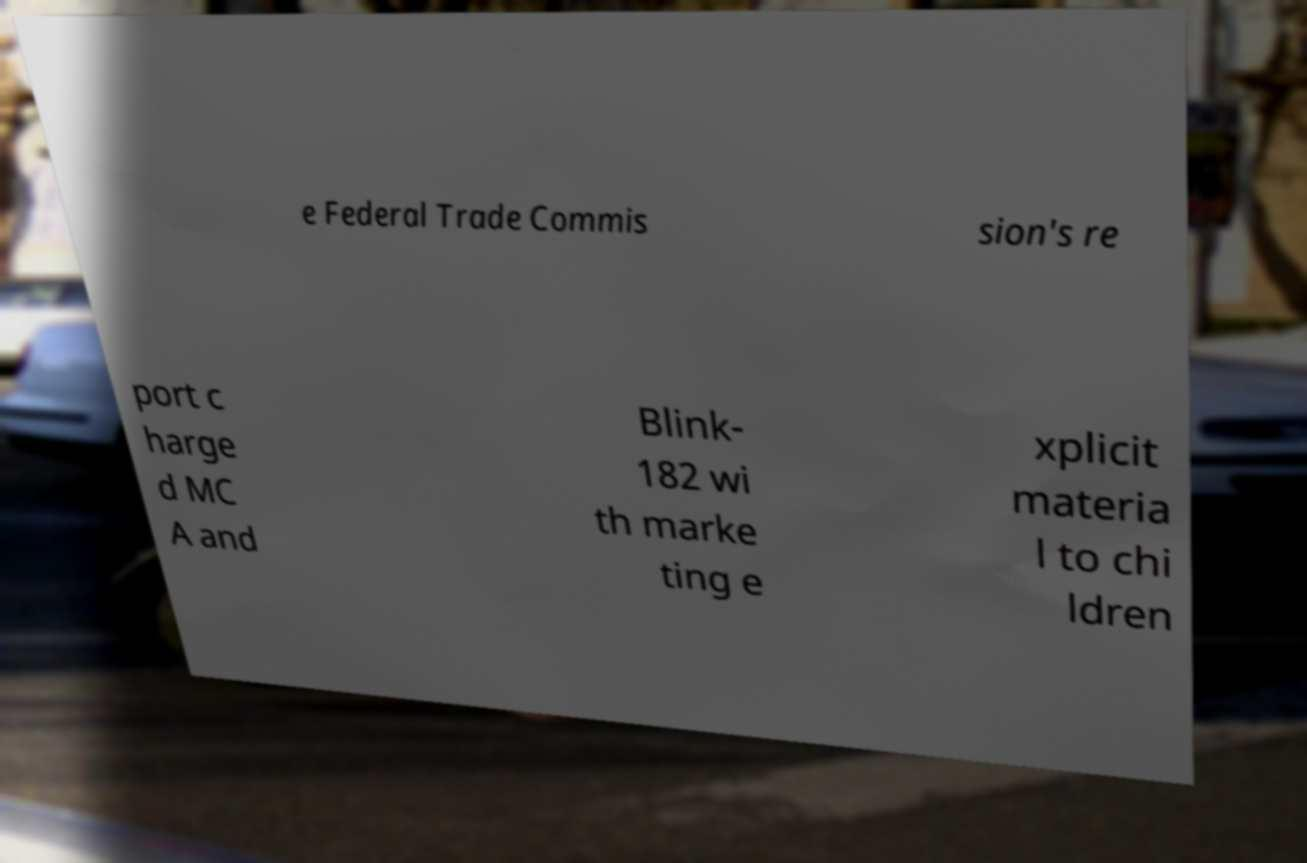Can you read and provide the text displayed in the image?This photo seems to have some interesting text. Can you extract and type it out for me? e Federal Trade Commis sion's re port c harge d MC A and Blink- 182 wi th marke ting e xplicit materia l to chi ldren 